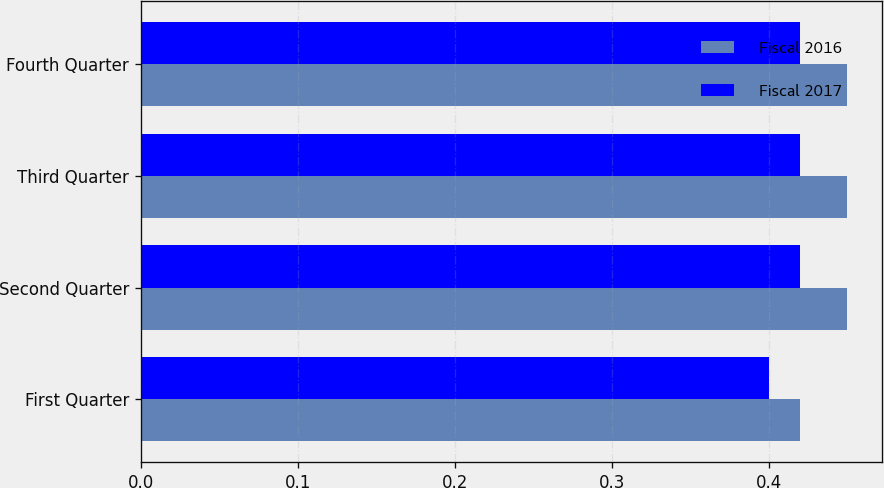Convert chart. <chart><loc_0><loc_0><loc_500><loc_500><stacked_bar_chart><ecel><fcel>First Quarter<fcel>Second Quarter<fcel>Third Quarter<fcel>Fourth Quarter<nl><fcel>Fiscal 2016<fcel>0.42<fcel>0.45<fcel>0.45<fcel>0.45<nl><fcel>Fiscal 2017<fcel>0.4<fcel>0.42<fcel>0.42<fcel>0.42<nl></chart> 